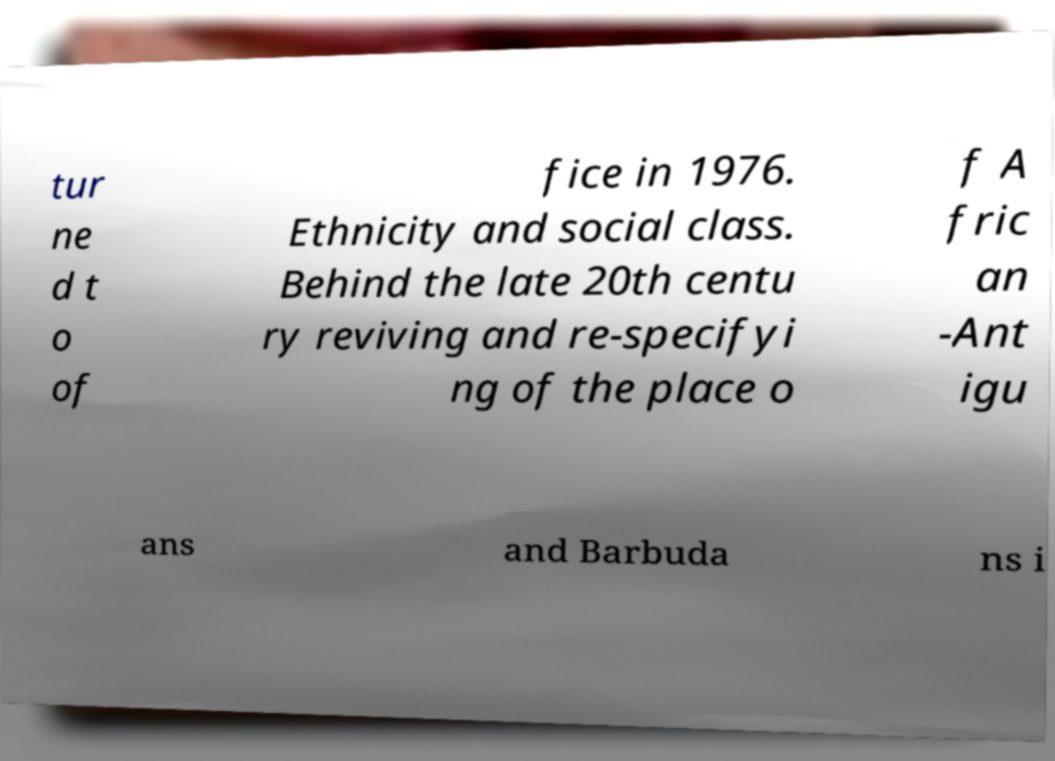There's text embedded in this image that I need extracted. Can you transcribe it verbatim? tur ne d t o of fice in 1976. Ethnicity and social class. Behind the late 20th centu ry reviving and re-specifyi ng of the place o f A fric an -Ant igu ans and Barbuda ns i 